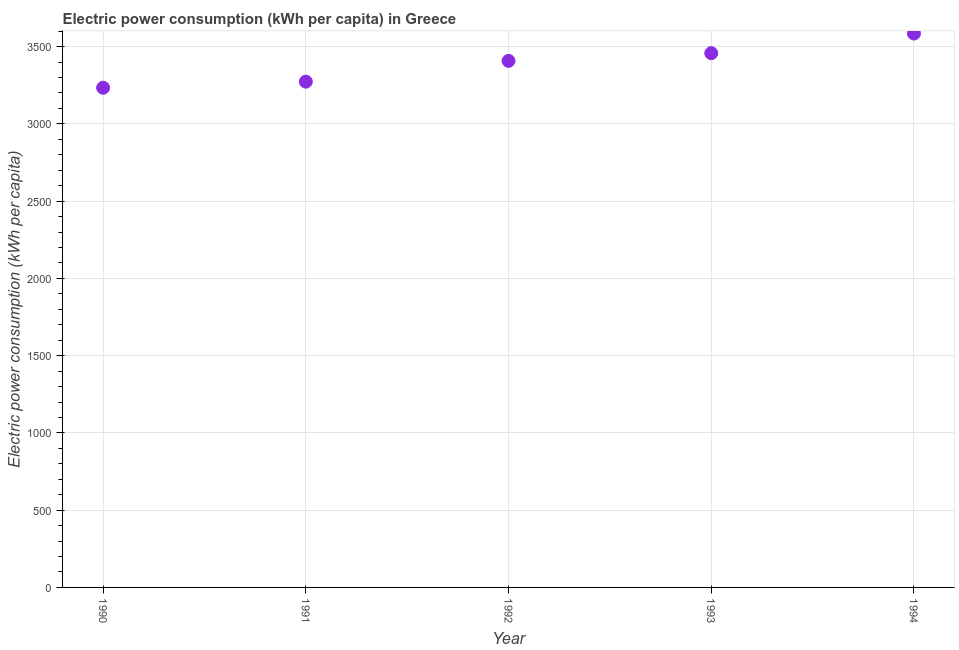What is the electric power consumption in 1993?
Provide a short and direct response. 3457.73. Across all years, what is the maximum electric power consumption?
Your response must be concise. 3584.85. Across all years, what is the minimum electric power consumption?
Your response must be concise. 3234.06. In which year was the electric power consumption maximum?
Your answer should be compact. 1994. In which year was the electric power consumption minimum?
Your response must be concise. 1990. What is the sum of the electric power consumption?
Offer a terse response. 1.70e+04. What is the difference between the electric power consumption in 1990 and 1993?
Your answer should be very brief. -223.68. What is the average electric power consumption per year?
Your answer should be very brief. 3391.6. What is the median electric power consumption?
Ensure brevity in your answer.  3407.95. Do a majority of the years between 1993 and 1990 (inclusive) have electric power consumption greater than 1400 kWh per capita?
Offer a terse response. Yes. What is the ratio of the electric power consumption in 1990 to that in 1991?
Give a very brief answer. 0.99. Is the electric power consumption in 1992 less than that in 1994?
Keep it short and to the point. Yes. What is the difference between the highest and the second highest electric power consumption?
Your response must be concise. 127.11. What is the difference between the highest and the lowest electric power consumption?
Give a very brief answer. 350.79. Does the electric power consumption monotonically increase over the years?
Your response must be concise. Yes. Does the graph contain any zero values?
Offer a very short reply. No. Does the graph contain grids?
Provide a succinct answer. Yes. What is the title of the graph?
Make the answer very short. Electric power consumption (kWh per capita) in Greece. What is the label or title of the X-axis?
Offer a very short reply. Year. What is the label or title of the Y-axis?
Offer a very short reply. Electric power consumption (kWh per capita). What is the Electric power consumption (kWh per capita) in 1990?
Offer a very short reply. 3234.06. What is the Electric power consumption (kWh per capita) in 1991?
Offer a terse response. 3273.41. What is the Electric power consumption (kWh per capita) in 1992?
Keep it short and to the point. 3407.95. What is the Electric power consumption (kWh per capita) in 1993?
Offer a terse response. 3457.73. What is the Electric power consumption (kWh per capita) in 1994?
Your response must be concise. 3584.85. What is the difference between the Electric power consumption (kWh per capita) in 1990 and 1991?
Keep it short and to the point. -39.35. What is the difference between the Electric power consumption (kWh per capita) in 1990 and 1992?
Your answer should be compact. -173.89. What is the difference between the Electric power consumption (kWh per capita) in 1990 and 1993?
Offer a terse response. -223.68. What is the difference between the Electric power consumption (kWh per capita) in 1990 and 1994?
Your answer should be compact. -350.79. What is the difference between the Electric power consumption (kWh per capita) in 1991 and 1992?
Give a very brief answer. -134.55. What is the difference between the Electric power consumption (kWh per capita) in 1991 and 1993?
Your response must be concise. -184.33. What is the difference between the Electric power consumption (kWh per capita) in 1991 and 1994?
Make the answer very short. -311.44. What is the difference between the Electric power consumption (kWh per capita) in 1992 and 1993?
Offer a terse response. -49.78. What is the difference between the Electric power consumption (kWh per capita) in 1992 and 1994?
Offer a terse response. -176.89. What is the difference between the Electric power consumption (kWh per capita) in 1993 and 1994?
Your answer should be very brief. -127.11. What is the ratio of the Electric power consumption (kWh per capita) in 1990 to that in 1991?
Give a very brief answer. 0.99. What is the ratio of the Electric power consumption (kWh per capita) in 1990 to that in 1992?
Provide a succinct answer. 0.95. What is the ratio of the Electric power consumption (kWh per capita) in 1990 to that in 1993?
Make the answer very short. 0.94. What is the ratio of the Electric power consumption (kWh per capita) in 1990 to that in 1994?
Provide a short and direct response. 0.9. What is the ratio of the Electric power consumption (kWh per capita) in 1991 to that in 1993?
Keep it short and to the point. 0.95. What is the ratio of the Electric power consumption (kWh per capita) in 1991 to that in 1994?
Ensure brevity in your answer.  0.91. What is the ratio of the Electric power consumption (kWh per capita) in 1992 to that in 1993?
Provide a succinct answer. 0.99. What is the ratio of the Electric power consumption (kWh per capita) in 1992 to that in 1994?
Your response must be concise. 0.95. What is the ratio of the Electric power consumption (kWh per capita) in 1993 to that in 1994?
Offer a terse response. 0.96. 